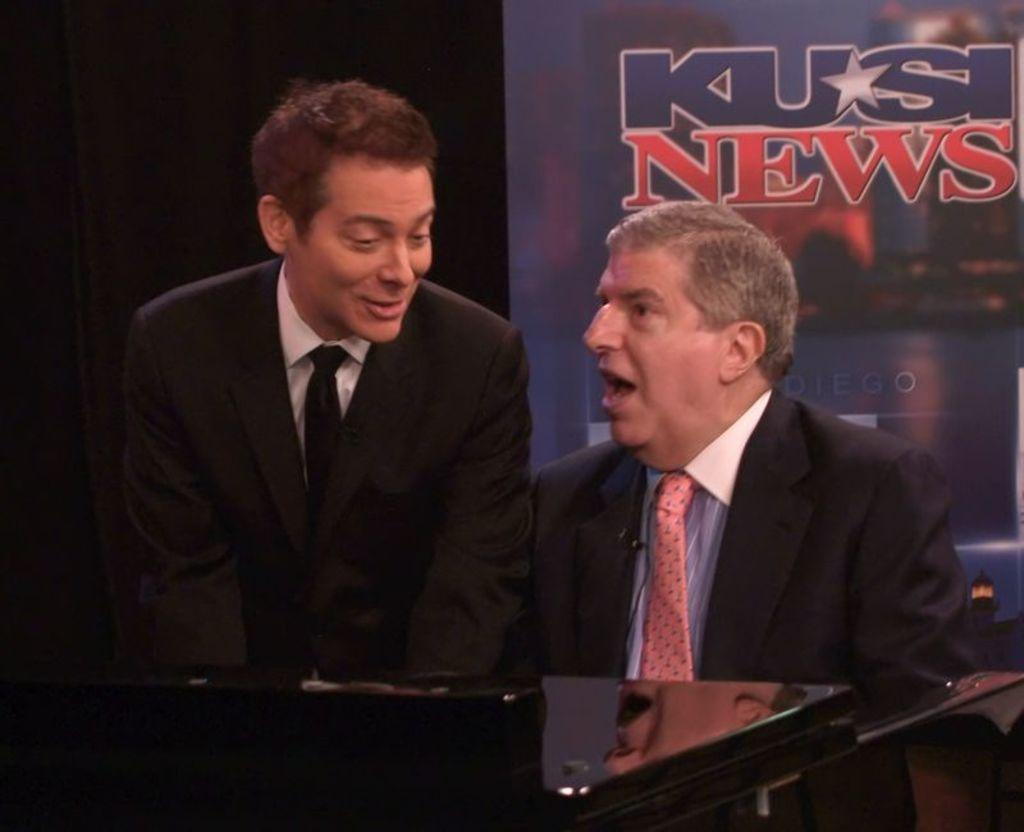What is the position of the man in the image? There is a man seated in the image. Are there any other people in the image? Yes, there is a man standing on the side in the image. What can be seen in the background of the image? There is an advertisement board visible in the image. What are the men wearing in the image? Both men are wearing coats. What is the purpose of the table in the image? The table's purpose cannot be determined from the provided facts. What type of plants are growing on the caption in the image? There is no caption or plants present in the image. How is the coal being used in the image? There is no coal present in the image. 